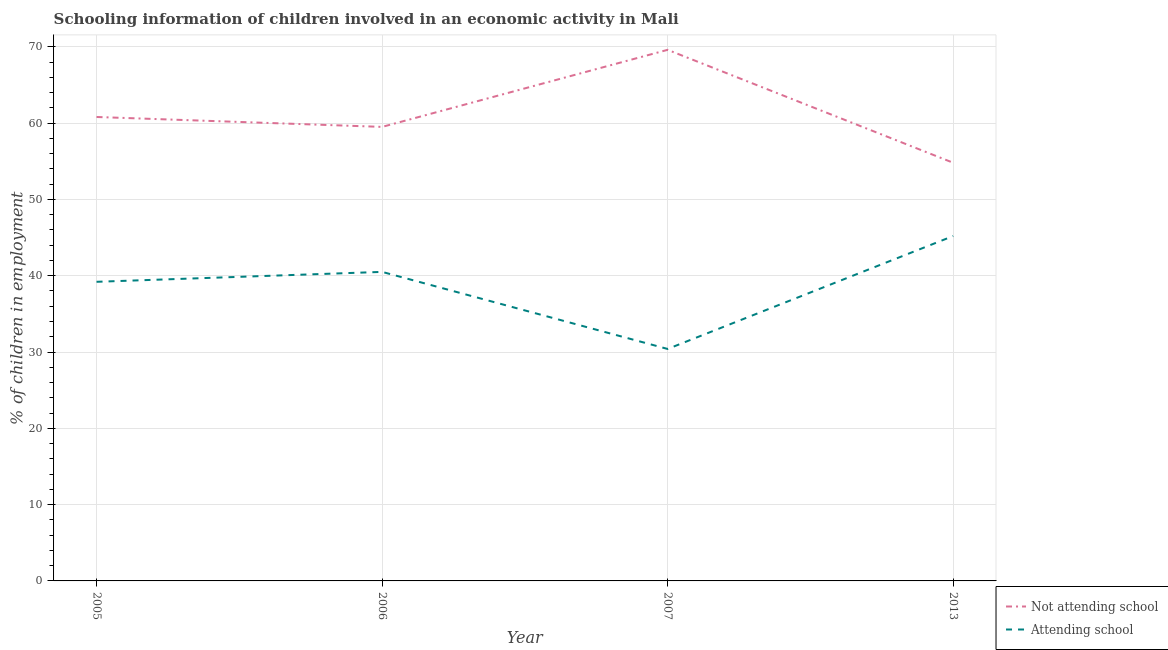How many different coloured lines are there?
Provide a short and direct response. 2. Does the line corresponding to percentage of employed children who are attending school intersect with the line corresponding to percentage of employed children who are not attending school?
Give a very brief answer. No. Is the number of lines equal to the number of legend labels?
Your answer should be very brief. Yes. What is the percentage of employed children who are not attending school in 2006?
Your answer should be very brief. 59.5. Across all years, what is the maximum percentage of employed children who are attending school?
Your answer should be compact. 45.2. Across all years, what is the minimum percentage of employed children who are attending school?
Your answer should be compact. 30.4. What is the total percentage of employed children who are not attending school in the graph?
Your response must be concise. 244.7. What is the difference between the percentage of employed children who are attending school in 2005 and that in 2013?
Provide a short and direct response. -6. What is the difference between the percentage of employed children who are attending school in 2006 and the percentage of employed children who are not attending school in 2013?
Keep it short and to the point. -14.3. What is the average percentage of employed children who are attending school per year?
Ensure brevity in your answer.  38.83. In the year 2013, what is the difference between the percentage of employed children who are attending school and percentage of employed children who are not attending school?
Give a very brief answer. -9.6. What is the ratio of the percentage of employed children who are attending school in 2005 to that in 2013?
Provide a succinct answer. 0.87. What is the difference between the highest and the second highest percentage of employed children who are attending school?
Keep it short and to the point. 4.7. What is the difference between the highest and the lowest percentage of employed children who are not attending school?
Provide a short and direct response. 14.8. Is the sum of the percentage of employed children who are not attending school in 2005 and 2013 greater than the maximum percentage of employed children who are attending school across all years?
Make the answer very short. Yes. Does the percentage of employed children who are attending school monotonically increase over the years?
Your answer should be very brief. No. How are the legend labels stacked?
Offer a terse response. Vertical. What is the title of the graph?
Ensure brevity in your answer.  Schooling information of children involved in an economic activity in Mali. Does "Non-residents" appear as one of the legend labels in the graph?
Give a very brief answer. No. What is the label or title of the Y-axis?
Give a very brief answer. % of children in employment. What is the % of children in employment in Not attending school in 2005?
Ensure brevity in your answer.  60.8. What is the % of children in employment in Attending school in 2005?
Your answer should be very brief. 39.2. What is the % of children in employment in Not attending school in 2006?
Offer a terse response. 59.5. What is the % of children in employment of Attending school in 2006?
Offer a terse response. 40.5. What is the % of children in employment in Not attending school in 2007?
Keep it short and to the point. 69.6. What is the % of children in employment in Attending school in 2007?
Ensure brevity in your answer.  30.4. What is the % of children in employment in Not attending school in 2013?
Your answer should be compact. 54.8. What is the % of children in employment in Attending school in 2013?
Ensure brevity in your answer.  45.2. Across all years, what is the maximum % of children in employment in Not attending school?
Offer a very short reply. 69.6. Across all years, what is the maximum % of children in employment in Attending school?
Your answer should be compact. 45.2. Across all years, what is the minimum % of children in employment in Not attending school?
Give a very brief answer. 54.8. Across all years, what is the minimum % of children in employment of Attending school?
Ensure brevity in your answer.  30.4. What is the total % of children in employment of Not attending school in the graph?
Give a very brief answer. 244.7. What is the total % of children in employment of Attending school in the graph?
Make the answer very short. 155.3. What is the difference between the % of children in employment of Not attending school in 2005 and that in 2007?
Ensure brevity in your answer.  -8.8. What is the difference between the % of children in employment in Attending school in 2005 and that in 2007?
Your response must be concise. 8.8. What is the difference between the % of children in employment in Not attending school in 2005 and that in 2013?
Give a very brief answer. 6. What is the difference between the % of children in employment of Attending school in 2006 and that in 2007?
Offer a very short reply. 10.1. What is the difference between the % of children in employment in Attending school in 2006 and that in 2013?
Keep it short and to the point. -4.7. What is the difference between the % of children in employment in Attending school in 2007 and that in 2013?
Your answer should be very brief. -14.8. What is the difference between the % of children in employment of Not attending school in 2005 and the % of children in employment of Attending school in 2006?
Your answer should be very brief. 20.3. What is the difference between the % of children in employment of Not attending school in 2005 and the % of children in employment of Attending school in 2007?
Your answer should be compact. 30.4. What is the difference between the % of children in employment in Not attending school in 2006 and the % of children in employment in Attending school in 2007?
Your answer should be very brief. 29.1. What is the difference between the % of children in employment of Not attending school in 2006 and the % of children in employment of Attending school in 2013?
Ensure brevity in your answer.  14.3. What is the difference between the % of children in employment of Not attending school in 2007 and the % of children in employment of Attending school in 2013?
Provide a succinct answer. 24.4. What is the average % of children in employment in Not attending school per year?
Offer a terse response. 61.17. What is the average % of children in employment in Attending school per year?
Keep it short and to the point. 38.83. In the year 2005, what is the difference between the % of children in employment of Not attending school and % of children in employment of Attending school?
Provide a short and direct response. 21.6. In the year 2006, what is the difference between the % of children in employment in Not attending school and % of children in employment in Attending school?
Make the answer very short. 19. In the year 2007, what is the difference between the % of children in employment in Not attending school and % of children in employment in Attending school?
Provide a succinct answer. 39.2. In the year 2013, what is the difference between the % of children in employment of Not attending school and % of children in employment of Attending school?
Make the answer very short. 9.6. What is the ratio of the % of children in employment in Not attending school in 2005 to that in 2006?
Ensure brevity in your answer.  1.02. What is the ratio of the % of children in employment of Attending school in 2005 to that in 2006?
Your answer should be compact. 0.97. What is the ratio of the % of children in employment of Not attending school in 2005 to that in 2007?
Ensure brevity in your answer.  0.87. What is the ratio of the % of children in employment in Attending school in 2005 to that in 2007?
Your answer should be very brief. 1.29. What is the ratio of the % of children in employment in Not attending school in 2005 to that in 2013?
Give a very brief answer. 1.11. What is the ratio of the % of children in employment in Attending school in 2005 to that in 2013?
Provide a short and direct response. 0.87. What is the ratio of the % of children in employment in Not attending school in 2006 to that in 2007?
Provide a short and direct response. 0.85. What is the ratio of the % of children in employment in Attending school in 2006 to that in 2007?
Keep it short and to the point. 1.33. What is the ratio of the % of children in employment of Not attending school in 2006 to that in 2013?
Offer a terse response. 1.09. What is the ratio of the % of children in employment in Attending school in 2006 to that in 2013?
Your response must be concise. 0.9. What is the ratio of the % of children in employment of Not attending school in 2007 to that in 2013?
Your answer should be very brief. 1.27. What is the ratio of the % of children in employment in Attending school in 2007 to that in 2013?
Your response must be concise. 0.67. What is the difference between the highest and the second highest % of children in employment in Attending school?
Provide a succinct answer. 4.7. 